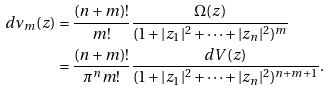Convert formula to latex. <formula><loc_0><loc_0><loc_500><loc_500>d \nu _ { m } ( z ) & = \frac { ( n + m ) ! } { m ! } \frac { \Omega ( z ) } { ( 1 + | z _ { 1 } | ^ { 2 } + \dots + | z _ { n } | ^ { 2 } ) ^ { m } } \\ & = \frac { ( n + m ) ! } { \pi ^ { n } m ! } \frac { d V ( z ) } { ( 1 + | z _ { 1 } | ^ { 2 } + \dots + | z _ { n } | ^ { 2 } ) ^ { n + m + 1 } } .</formula> 